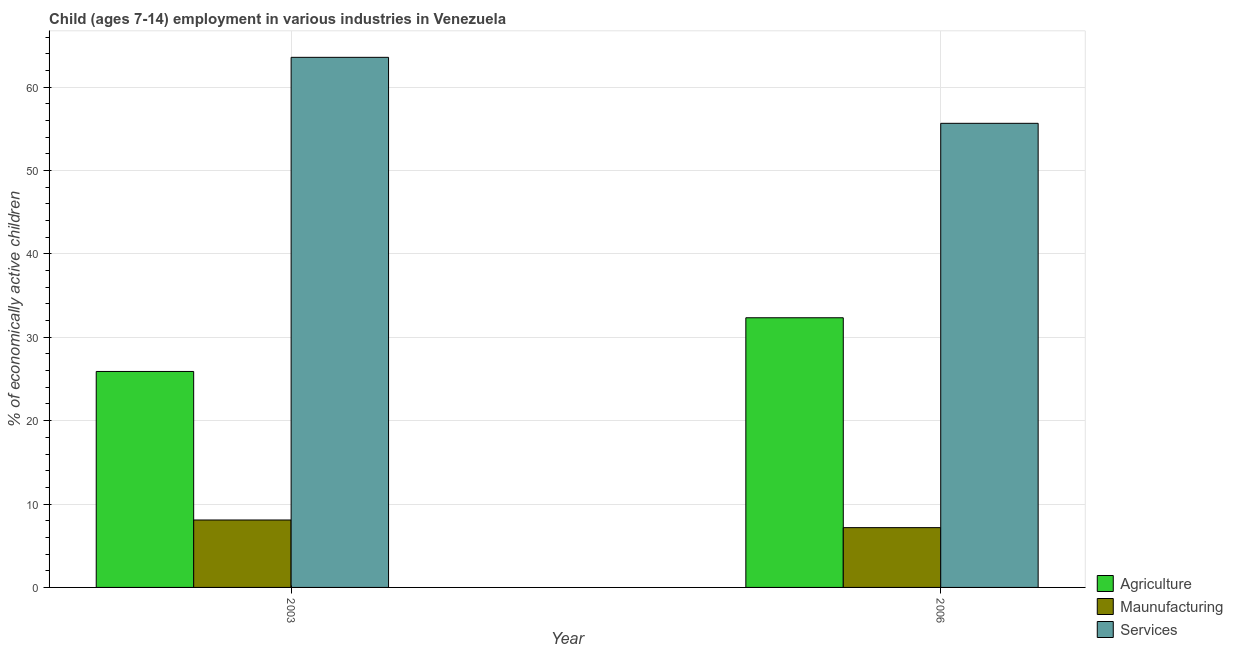How many different coloured bars are there?
Your answer should be compact. 3. What is the label of the 2nd group of bars from the left?
Give a very brief answer. 2006. What is the percentage of economically active children in services in 2003?
Provide a short and direct response. 63.57. Across all years, what is the maximum percentage of economically active children in services?
Provide a short and direct response. 63.57. Across all years, what is the minimum percentage of economically active children in agriculture?
Your answer should be very brief. 25.9. In which year was the percentage of economically active children in agriculture minimum?
Ensure brevity in your answer.  2003. What is the total percentage of economically active children in services in the graph?
Give a very brief answer. 119.23. What is the difference between the percentage of economically active children in services in 2003 and that in 2006?
Give a very brief answer. 7.91. What is the difference between the percentage of economically active children in services in 2006 and the percentage of economically active children in manufacturing in 2003?
Your answer should be very brief. -7.91. What is the average percentage of economically active children in manufacturing per year?
Offer a very short reply. 7.63. What is the ratio of the percentage of economically active children in agriculture in 2003 to that in 2006?
Ensure brevity in your answer.  0.8. Is the percentage of economically active children in services in 2003 less than that in 2006?
Offer a very short reply. No. What does the 3rd bar from the left in 2006 represents?
Your response must be concise. Services. What does the 3rd bar from the right in 2006 represents?
Provide a succinct answer. Agriculture. Is it the case that in every year, the sum of the percentage of economically active children in agriculture and percentage of economically active children in manufacturing is greater than the percentage of economically active children in services?
Your answer should be compact. No. How many years are there in the graph?
Provide a succinct answer. 2. What is the difference between two consecutive major ticks on the Y-axis?
Your answer should be very brief. 10. Are the values on the major ticks of Y-axis written in scientific E-notation?
Make the answer very short. No. Does the graph contain grids?
Give a very brief answer. Yes. How many legend labels are there?
Your answer should be very brief. 3. What is the title of the graph?
Provide a succinct answer. Child (ages 7-14) employment in various industries in Venezuela. What is the label or title of the Y-axis?
Offer a terse response. % of economically active children. What is the % of economically active children of Agriculture in 2003?
Make the answer very short. 25.9. What is the % of economically active children in Maunufacturing in 2003?
Make the answer very short. 8.09. What is the % of economically active children of Services in 2003?
Keep it short and to the point. 63.57. What is the % of economically active children of Agriculture in 2006?
Give a very brief answer. 32.34. What is the % of economically active children in Maunufacturing in 2006?
Keep it short and to the point. 7.17. What is the % of economically active children in Services in 2006?
Keep it short and to the point. 55.66. Across all years, what is the maximum % of economically active children in Agriculture?
Keep it short and to the point. 32.34. Across all years, what is the maximum % of economically active children of Maunufacturing?
Your response must be concise. 8.09. Across all years, what is the maximum % of economically active children in Services?
Your answer should be very brief. 63.57. Across all years, what is the minimum % of economically active children of Agriculture?
Offer a very short reply. 25.9. Across all years, what is the minimum % of economically active children of Maunufacturing?
Ensure brevity in your answer.  7.17. Across all years, what is the minimum % of economically active children of Services?
Give a very brief answer. 55.66. What is the total % of economically active children in Agriculture in the graph?
Your response must be concise. 58.24. What is the total % of economically active children in Maunufacturing in the graph?
Your answer should be very brief. 15.26. What is the total % of economically active children in Services in the graph?
Provide a succinct answer. 119.23. What is the difference between the % of economically active children in Agriculture in 2003 and that in 2006?
Give a very brief answer. -6.44. What is the difference between the % of economically active children of Maunufacturing in 2003 and that in 2006?
Give a very brief answer. 0.92. What is the difference between the % of economically active children in Services in 2003 and that in 2006?
Offer a very short reply. 7.91. What is the difference between the % of economically active children in Agriculture in 2003 and the % of economically active children in Maunufacturing in 2006?
Ensure brevity in your answer.  18.73. What is the difference between the % of economically active children of Agriculture in 2003 and the % of economically active children of Services in 2006?
Your answer should be very brief. -29.76. What is the difference between the % of economically active children of Maunufacturing in 2003 and the % of economically active children of Services in 2006?
Offer a terse response. -47.57. What is the average % of economically active children of Agriculture per year?
Give a very brief answer. 29.12. What is the average % of economically active children in Maunufacturing per year?
Ensure brevity in your answer.  7.63. What is the average % of economically active children of Services per year?
Offer a very short reply. 59.62. In the year 2003, what is the difference between the % of economically active children of Agriculture and % of economically active children of Maunufacturing?
Ensure brevity in your answer.  17.81. In the year 2003, what is the difference between the % of economically active children of Agriculture and % of economically active children of Services?
Offer a very short reply. -37.67. In the year 2003, what is the difference between the % of economically active children of Maunufacturing and % of economically active children of Services?
Ensure brevity in your answer.  -55.49. In the year 2006, what is the difference between the % of economically active children of Agriculture and % of economically active children of Maunufacturing?
Give a very brief answer. 25.17. In the year 2006, what is the difference between the % of economically active children in Agriculture and % of economically active children in Services?
Offer a very short reply. -23.32. In the year 2006, what is the difference between the % of economically active children of Maunufacturing and % of economically active children of Services?
Give a very brief answer. -48.49. What is the ratio of the % of economically active children in Agriculture in 2003 to that in 2006?
Your answer should be compact. 0.8. What is the ratio of the % of economically active children in Maunufacturing in 2003 to that in 2006?
Offer a very short reply. 1.13. What is the ratio of the % of economically active children of Services in 2003 to that in 2006?
Offer a very short reply. 1.14. What is the difference between the highest and the second highest % of economically active children in Agriculture?
Your response must be concise. 6.44. What is the difference between the highest and the second highest % of economically active children of Maunufacturing?
Your answer should be very brief. 0.92. What is the difference between the highest and the second highest % of economically active children in Services?
Ensure brevity in your answer.  7.91. What is the difference between the highest and the lowest % of economically active children of Agriculture?
Offer a very short reply. 6.44. What is the difference between the highest and the lowest % of economically active children of Maunufacturing?
Your answer should be compact. 0.92. What is the difference between the highest and the lowest % of economically active children in Services?
Keep it short and to the point. 7.91. 